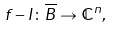Convert formula to latex. <formula><loc_0><loc_0><loc_500><loc_500>f - I \colon \overline { B } \rightarrow \mathbb { C } ^ { n } ,</formula> 